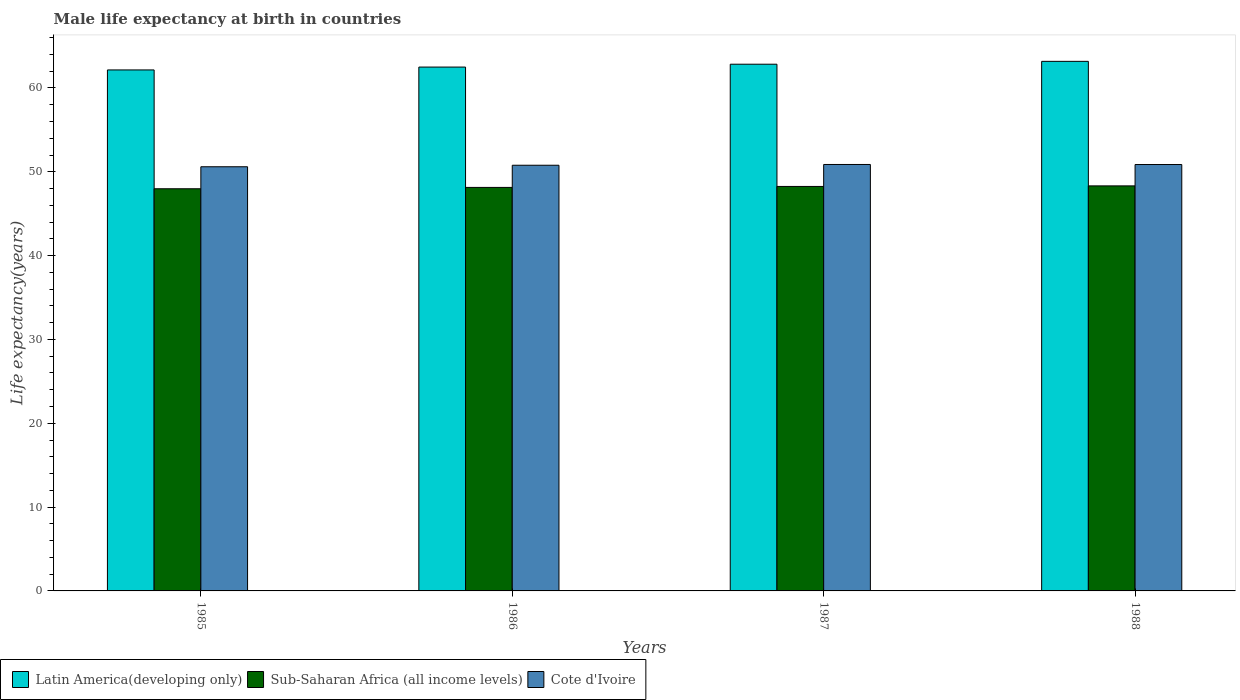How many different coloured bars are there?
Make the answer very short. 3. Are the number of bars per tick equal to the number of legend labels?
Your response must be concise. Yes. Are the number of bars on each tick of the X-axis equal?
Ensure brevity in your answer.  Yes. How many bars are there on the 4th tick from the left?
Give a very brief answer. 3. How many bars are there on the 3rd tick from the right?
Give a very brief answer. 3. What is the male life expectancy at birth in Latin America(developing only) in 1987?
Your answer should be compact. 62.83. Across all years, what is the maximum male life expectancy at birth in Cote d'Ivoire?
Ensure brevity in your answer.  50.87. Across all years, what is the minimum male life expectancy at birth in Cote d'Ivoire?
Provide a short and direct response. 50.6. In which year was the male life expectancy at birth in Latin America(developing only) maximum?
Your answer should be compact. 1988. In which year was the male life expectancy at birth in Sub-Saharan Africa (all income levels) minimum?
Provide a succinct answer. 1985. What is the total male life expectancy at birth in Cote d'Ivoire in the graph?
Give a very brief answer. 203.12. What is the difference between the male life expectancy at birth in Latin America(developing only) in 1985 and that in 1988?
Ensure brevity in your answer.  -1.02. What is the difference between the male life expectancy at birth in Latin America(developing only) in 1986 and the male life expectancy at birth in Sub-Saharan Africa (all income levels) in 1987?
Your answer should be very brief. 14.24. What is the average male life expectancy at birth in Cote d'Ivoire per year?
Provide a short and direct response. 50.78. In the year 1985, what is the difference between the male life expectancy at birth in Cote d'Ivoire and male life expectancy at birth in Latin America(developing only)?
Your response must be concise. -11.55. What is the ratio of the male life expectancy at birth in Sub-Saharan Africa (all income levels) in 1987 to that in 1988?
Offer a terse response. 1. Is the male life expectancy at birth in Latin America(developing only) in 1985 less than that in 1986?
Ensure brevity in your answer.  Yes. Is the difference between the male life expectancy at birth in Cote d'Ivoire in 1985 and 1988 greater than the difference between the male life expectancy at birth in Latin America(developing only) in 1985 and 1988?
Keep it short and to the point. Yes. What is the difference between the highest and the second highest male life expectancy at birth in Latin America(developing only)?
Your answer should be compact. 0.34. What is the difference between the highest and the lowest male life expectancy at birth in Sub-Saharan Africa (all income levels)?
Provide a succinct answer. 0.34. What does the 2nd bar from the left in 1985 represents?
Your response must be concise. Sub-Saharan Africa (all income levels). What does the 2nd bar from the right in 1986 represents?
Offer a very short reply. Sub-Saharan Africa (all income levels). How many bars are there?
Your response must be concise. 12. Does the graph contain any zero values?
Offer a very short reply. No. How are the legend labels stacked?
Your response must be concise. Horizontal. What is the title of the graph?
Provide a succinct answer. Male life expectancy at birth in countries. Does "St. Martin (French part)" appear as one of the legend labels in the graph?
Your response must be concise. No. What is the label or title of the X-axis?
Your answer should be compact. Years. What is the label or title of the Y-axis?
Your answer should be compact. Life expectancy(years). What is the Life expectancy(years) in Latin America(developing only) in 1985?
Provide a succinct answer. 62.15. What is the Life expectancy(years) in Sub-Saharan Africa (all income levels) in 1985?
Make the answer very short. 47.97. What is the Life expectancy(years) in Cote d'Ivoire in 1985?
Offer a very short reply. 50.6. What is the Life expectancy(years) in Latin America(developing only) in 1986?
Offer a very short reply. 62.49. What is the Life expectancy(years) in Sub-Saharan Africa (all income levels) in 1986?
Your answer should be compact. 48.13. What is the Life expectancy(years) in Cote d'Ivoire in 1986?
Provide a short and direct response. 50.78. What is the Life expectancy(years) of Latin America(developing only) in 1987?
Provide a short and direct response. 62.83. What is the Life expectancy(years) in Sub-Saharan Africa (all income levels) in 1987?
Make the answer very short. 48.25. What is the Life expectancy(years) in Cote d'Ivoire in 1987?
Offer a very short reply. 50.87. What is the Life expectancy(years) of Latin America(developing only) in 1988?
Provide a short and direct response. 63.17. What is the Life expectancy(years) in Sub-Saharan Africa (all income levels) in 1988?
Your answer should be compact. 48.32. What is the Life expectancy(years) of Cote d'Ivoire in 1988?
Your answer should be very brief. 50.87. Across all years, what is the maximum Life expectancy(years) of Latin America(developing only)?
Provide a succinct answer. 63.17. Across all years, what is the maximum Life expectancy(years) of Sub-Saharan Africa (all income levels)?
Ensure brevity in your answer.  48.32. Across all years, what is the maximum Life expectancy(years) of Cote d'Ivoire?
Give a very brief answer. 50.87. Across all years, what is the minimum Life expectancy(years) in Latin America(developing only)?
Offer a terse response. 62.15. Across all years, what is the minimum Life expectancy(years) of Sub-Saharan Africa (all income levels)?
Your answer should be very brief. 47.97. Across all years, what is the minimum Life expectancy(years) in Cote d'Ivoire?
Your answer should be compact. 50.6. What is the total Life expectancy(years) in Latin America(developing only) in the graph?
Offer a terse response. 250.64. What is the total Life expectancy(years) of Sub-Saharan Africa (all income levels) in the graph?
Your answer should be compact. 192.68. What is the total Life expectancy(years) of Cote d'Ivoire in the graph?
Provide a succinct answer. 203.12. What is the difference between the Life expectancy(years) of Latin America(developing only) in 1985 and that in 1986?
Provide a succinct answer. -0.34. What is the difference between the Life expectancy(years) in Sub-Saharan Africa (all income levels) in 1985 and that in 1986?
Keep it short and to the point. -0.16. What is the difference between the Life expectancy(years) of Cote d'Ivoire in 1985 and that in 1986?
Make the answer very short. -0.18. What is the difference between the Life expectancy(years) in Latin America(developing only) in 1985 and that in 1987?
Provide a short and direct response. -0.68. What is the difference between the Life expectancy(years) in Sub-Saharan Africa (all income levels) in 1985 and that in 1987?
Your answer should be compact. -0.28. What is the difference between the Life expectancy(years) in Cote d'Ivoire in 1985 and that in 1987?
Offer a very short reply. -0.27. What is the difference between the Life expectancy(years) of Latin America(developing only) in 1985 and that in 1988?
Your response must be concise. -1.02. What is the difference between the Life expectancy(years) in Sub-Saharan Africa (all income levels) in 1985 and that in 1988?
Your response must be concise. -0.34. What is the difference between the Life expectancy(years) of Cote d'Ivoire in 1985 and that in 1988?
Offer a terse response. -0.27. What is the difference between the Life expectancy(years) in Latin America(developing only) in 1986 and that in 1987?
Offer a terse response. -0.34. What is the difference between the Life expectancy(years) of Sub-Saharan Africa (all income levels) in 1986 and that in 1987?
Your answer should be very brief. -0.12. What is the difference between the Life expectancy(years) of Cote d'Ivoire in 1986 and that in 1987?
Provide a short and direct response. -0.09. What is the difference between the Life expectancy(years) of Latin America(developing only) in 1986 and that in 1988?
Ensure brevity in your answer.  -0.68. What is the difference between the Life expectancy(years) of Sub-Saharan Africa (all income levels) in 1986 and that in 1988?
Provide a short and direct response. -0.18. What is the difference between the Life expectancy(years) of Cote d'Ivoire in 1986 and that in 1988?
Offer a very short reply. -0.09. What is the difference between the Life expectancy(years) in Latin America(developing only) in 1987 and that in 1988?
Give a very brief answer. -0.34. What is the difference between the Life expectancy(years) of Sub-Saharan Africa (all income levels) in 1987 and that in 1988?
Make the answer very short. -0.07. What is the difference between the Life expectancy(years) of Cote d'Ivoire in 1987 and that in 1988?
Your answer should be compact. 0.01. What is the difference between the Life expectancy(years) of Latin America(developing only) in 1985 and the Life expectancy(years) of Sub-Saharan Africa (all income levels) in 1986?
Provide a short and direct response. 14.01. What is the difference between the Life expectancy(years) in Latin America(developing only) in 1985 and the Life expectancy(years) in Cote d'Ivoire in 1986?
Ensure brevity in your answer.  11.37. What is the difference between the Life expectancy(years) in Sub-Saharan Africa (all income levels) in 1985 and the Life expectancy(years) in Cote d'Ivoire in 1986?
Your response must be concise. -2.8. What is the difference between the Life expectancy(years) in Latin America(developing only) in 1985 and the Life expectancy(years) in Sub-Saharan Africa (all income levels) in 1987?
Offer a terse response. 13.9. What is the difference between the Life expectancy(years) in Latin America(developing only) in 1985 and the Life expectancy(years) in Cote d'Ivoire in 1987?
Give a very brief answer. 11.28. What is the difference between the Life expectancy(years) of Sub-Saharan Africa (all income levels) in 1985 and the Life expectancy(years) of Cote d'Ivoire in 1987?
Your answer should be very brief. -2.9. What is the difference between the Life expectancy(years) of Latin America(developing only) in 1985 and the Life expectancy(years) of Sub-Saharan Africa (all income levels) in 1988?
Provide a succinct answer. 13.83. What is the difference between the Life expectancy(years) in Latin America(developing only) in 1985 and the Life expectancy(years) in Cote d'Ivoire in 1988?
Offer a terse response. 11.28. What is the difference between the Life expectancy(years) of Sub-Saharan Africa (all income levels) in 1985 and the Life expectancy(years) of Cote d'Ivoire in 1988?
Offer a very short reply. -2.89. What is the difference between the Life expectancy(years) of Latin America(developing only) in 1986 and the Life expectancy(years) of Sub-Saharan Africa (all income levels) in 1987?
Ensure brevity in your answer.  14.24. What is the difference between the Life expectancy(years) in Latin America(developing only) in 1986 and the Life expectancy(years) in Cote d'Ivoire in 1987?
Ensure brevity in your answer.  11.62. What is the difference between the Life expectancy(years) in Sub-Saharan Africa (all income levels) in 1986 and the Life expectancy(years) in Cote d'Ivoire in 1987?
Give a very brief answer. -2.74. What is the difference between the Life expectancy(years) of Latin America(developing only) in 1986 and the Life expectancy(years) of Sub-Saharan Africa (all income levels) in 1988?
Offer a very short reply. 14.17. What is the difference between the Life expectancy(years) of Latin America(developing only) in 1986 and the Life expectancy(years) of Cote d'Ivoire in 1988?
Keep it short and to the point. 11.63. What is the difference between the Life expectancy(years) in Sub-Saharan Africa (all income levels) in 1986 and the Life expectancy(years) in Cote d'Ivoire in 1988?
Offer a terse response. -2.73. What is the difference between the Life expectancy(years) of Latin America(developing only) in 1987 and the Life expectancy(years) of Sub-Saharan Africa (all income levels) in 1988?
Offer a very short reply. 14.52. What is the difference between the Life expectancy(years) in Latin America(developing only) in 1987 and the Life expectancy(years) in Cote d'Ivoire in 1988?
Provide a short and direct response. 11.97. What is the difference between the Life expectancy(years) in Sub-Saharan Africa (all income levels) in 1987 and the Life expectancy(years) in Cote d'Ivoire in 1988?
Give a very brief answer. -2.62. What is the average Life expectancy(years) in Latin America(developing only) per year?
Your answer should be very brief. 62.66. What is the average Life expectancy(years) of Sub-Saharan Africa (all income levels) per year?
Give a very brief answer. 48.17. What is the average Life expectancy(years) in Cote d'Ivoire per year?
Keep it short and to the point. 50.78. In the year 1985, what is the difference between the Life expectancy(years) in Latin America(developing only) and Life expectancy(years) in Sub-Saharan Africa (all income levels)?
Give a very brief answer. 14.17. In the year 1985, what is the difference between the Life expectancy(years) in Latin America(developing only) and Life expectancy(years) in Cote d'Ivoire?
Ensure brevity in your answer.  11.55. In the year 1985, what is the difference between the Life expectancy(years) in Sub-Saharan Africa (all income levels) and Life expectancy(years) in Cote d'Ivoire?
Keep it short and to the point. -2.62. In the year 1986, what is the difference between the Life expectancy(years) of Latin America(developing only) and Life expectancy(years) of Sub-Saharan Africa (all income levels)?
Offer a terse response. 14.36. In the year 1986, what is the difference between the Life expectancy(years) of Latin America(developing only) and Life expectancy(years) of Cote d'Ivoire?
Your answer should be very brief. 11.71. In the year 1986, what is the difference between the Life expectancy(years) in Sub-Saharan Africa (all income levels) and Life expectancy(years) in Cote d'Ivoire?
Ensure brevity in your answer.  -2.64. In the year 1987, what is the difference between the Life expectancy(years) in Latin America(developing only) and Life expectancy(years) in Sub-Saharan Africa (all income levels)?
Provide a succinct answer. 14.58. In the year 1987, what is the difference between the Life expectancy(years) in Latin America(developing only) and Life expectancy(years) in Cote d'Ivoire?
Keep it short and to the point. 11.96. In the year 1987, what is the difference between the Life expectancy(years) of Sub-Saharan Africa (all income levels) and Life expectancy(years) of Cote d'Ivoire?
Ensure brevity in your answer.  -2.62. In the year 1988, what is the difference between the Life expectancy(years) of Latin America(developing only) and Life expectancy(years) of Sub-Saharan Africa (all income levels)?
Offer a very short reply. 14.86. In the year 1988, what is the difference between the Life expectancy(years) of Latin America(developing only) and Life expectancy(years) of Cote d'Ivoire?
Your response must be concise. 12.31. In the year 1988, what is the difference between the Life expectancy(years) of Sub-Saharan Africa (all income levels) and Life expectancy(years) of Cote d'Ivoire?
Make the answer very short. -2.55. What is the ratio of the Life expectancy(years) in Latin America(developing only) in 1985 to that in 1986?
Provide a succinct answer. 0.99. What is the ratio of the Life expectancy(years) of Sub-Saharan Africa (all income levels) in 1985 to that in 1987?
Give a very brief answer. 0.99. What is the ratio of the Life expectancy(years) of Latin America(developing only) in 1985 to that in 1988?
Give a very brief answer. 0.98. What is the ratio of the Life expectancy(years) in Sub-Saharan Africa (all income levels) in 1985 to that in 1988?
Offer a very short reply. 0.99. What is the ratio of the Life expectancy(years) of Latin America(developing only) in 1986 to that in 1987?
Provide a short and direct response. 0.99. What is the ratio of the Life expectancy(years) in Sub-Saharan Africa (all income levels) in 1986 to that in 1987?
Make the answer very short. 1. What is the ratio of the Life expectancy(years) of Sub-Saharan Africa (all income levels) in 1986 to that in 1988?
Your answer should be very brief. 1. What is the ratio of the Life expectancy(years) of Cote d'Ivoire in 1986 to that in 1988?
Keep it short and to the point. 1. What is the difference between the highest and the second highest Life expectancy(years) in Latin America(developing only)?
Offer a very short reply. 0.34. What is the difference between the highest and the second highest Life expectancy(years) in Sub-Saharan Africa (all income levels)?
Offer a terse response. 0.07. What is the difference between the highest and the second highest Life expectancy(years) in Cote d'Ivoire?
Offer a very short reply. 0.01. What is the difference between the highest and the lowest Life expectancy(years) of Latin America(developing only)?
Provide a succinct answer. 1.02. What is the difference between the highest and the lowest Life expectancy(years) of Sub-Saharan Africa (all income levels)?
Keep it short and to the point. 0.34. What is the difference between the highest and the lowest Life expectancy(years) in Cote d'Ivoire?
Your response must be concise. 0.27. 